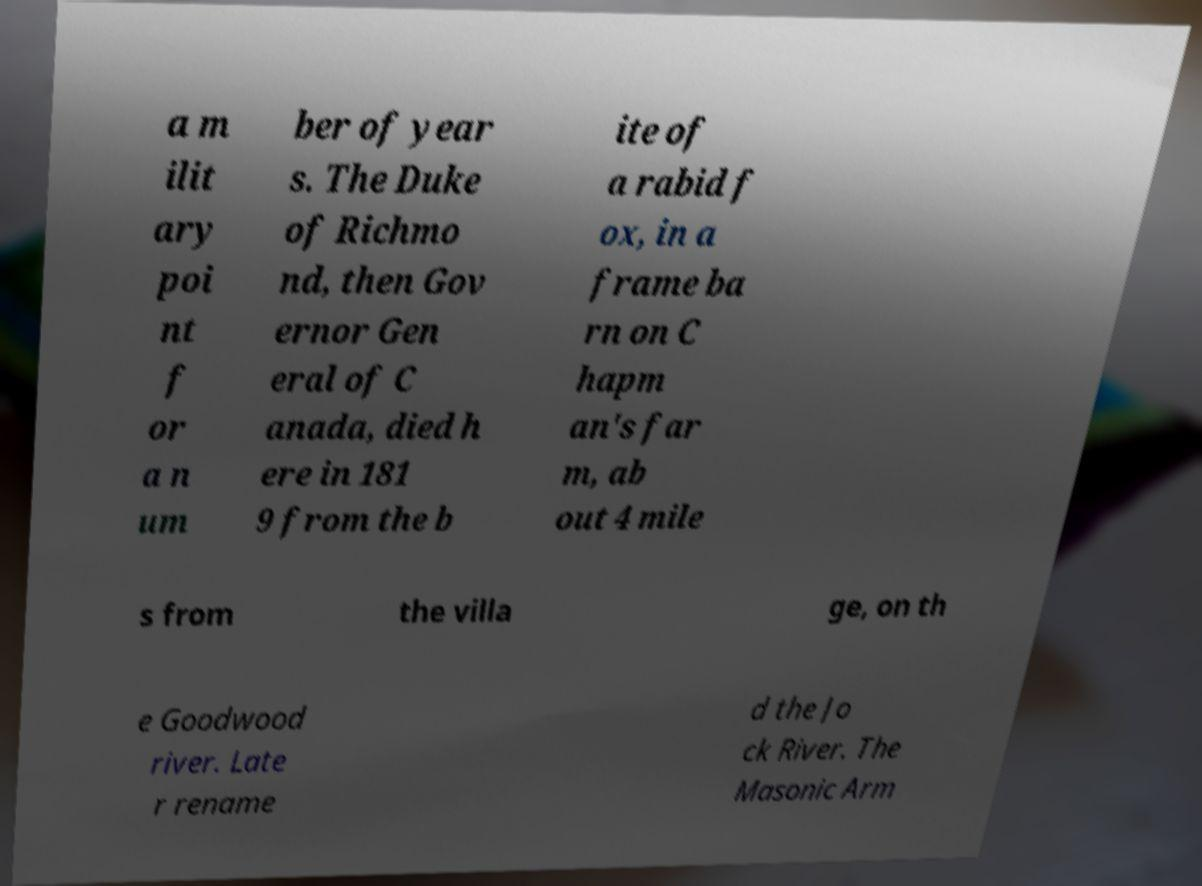Please read and relay the text visible in this image. What does it say? a m ilit ary poi nt f or a n um ber of year s. The Duke of Richmo nd, then Gov ernor Gen eral of C anada, died h ere in 181 9 from the b ite of a rabid f ox, in a frame ba rn on C hapm an's far m, ab out 4 mile s from the villa ge, on th e Goodwood river. Late r rename d the Jo ck River. The Masonic Arm 